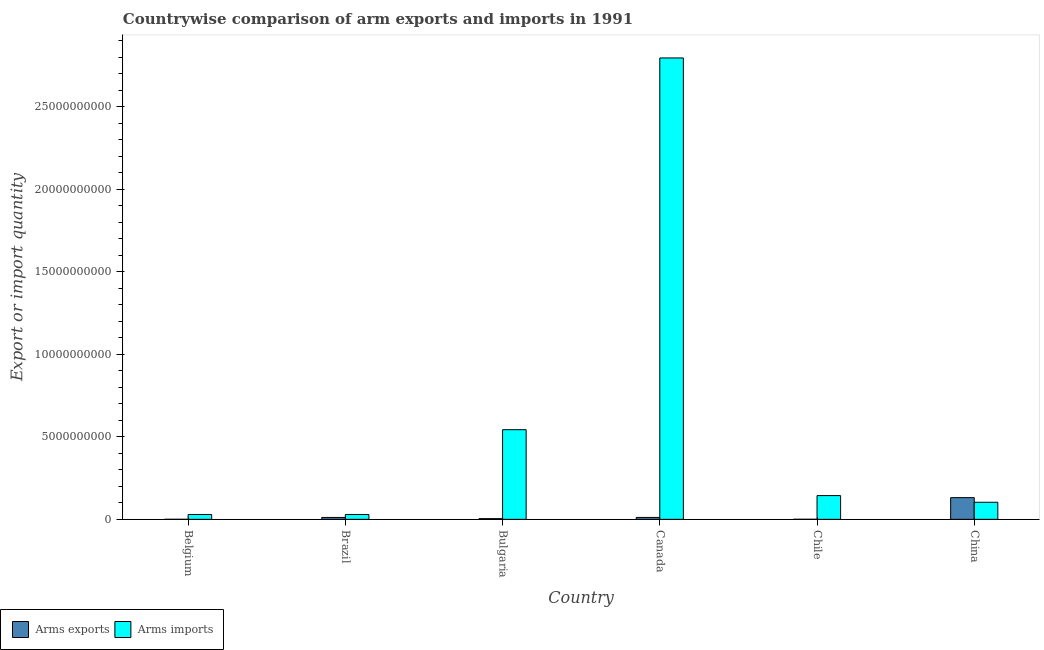How many groups of bars are there?
Your response must be concise. 6. Are the number of bars per tick equal to the number of legend labels?
Offer a very short reply. Yes. How many bars are there on the 3rd tick from the left?
Provide a succinct answer. 2. How many bars are there on the 1st tick from the right?
Ensure brevity in your answer.  2. What is the label of the 4th group of bars from the left?
Your answer should be compact. Canada. What is the arms imports in China?
Provide a short and direct response. 1.04e+09. Across all countries, what is the maximum arms imports?
Make the answer very short. 2.80e+1. Across all countries, what is the minimum arms imports?
Keep it short and to the point. 2.94e+08. In which country was the arms imports maximum?
Your answer should be very brief. Canada. What is the total arms exports in the graph?
Your response must be concise. 1.59e+09. What is the difference between the arms imports in Bulgaria and that in Chile?
Provide a short and direct response. 4.00e+09. What is the difference between the arms exports in China and the arms imports in Belgium?
Make the answer very short. 1.02e+09. What is the average arms exports per country?
Your answer should be compact. 2.65e+08. What is the difference between the arms imports and arms exports in Belgium?
Provide a succinct answer. 2.93e+08. In how many countries, is the arms imports greater than 28000000000 ?
Offer a very short reply. 0. What is the ratio of the arms imports in Brazil to that in Bulgaria?
Make the answer very short. 0.05. Is the arms exports in Belgium less than that in Brazil?
Give a very brief answer. Yes. What is the difference between the highest and the second highest arms imports?
Offer a very short reply. 2.25e+1. What is the difference between the highest and the lowest arms exports?
Offer a terse response. 1.31e+09. What does the 2nd bar from the left in Brazil represents?
Provide a short and direct response. Arms imports. What does the 2nd bar from the right in Canada represents?
Provide a short and direct response. Arms exports. Are the values on the major ticks of Y-axis written in scientific E-notation?
Offer a very short reply. No. Does the graph contain any zero values?
Your response must be concise. No. Does the graph contain grids?
Make the answer very short. No. How many legend labels are there?
Your response must be concise. 2. How are the legend labels stacked?
Offer a very short reply. Horizontal. What is the title of the graph?
Your answer should be compact. Countrywise comparison of arm exports and imports in 1991. What is the label or title of the Y-axis?
Provide a succinct answer. Export or import quantity. What is the Export or import quantity of Arms imports in Belgium?
Give a very brief answer. 2.94e+08. What is the Export or import quantity in Arms exports in Brazil?
Provide a short and direct response. 1.14e+08. What is the Export or import quantity of Arms imports in Brazil?
Ensure brevity in your answer.  2.94e+08. What is the Export or import quantity of Arms exports in Bulgaria?
Keep it short and to the point. 4.20e+07. What is the Export or import quantity of Arms imports in Bulgaria?
Give a very brief answer. 5.43e+09. What is the Export or import quantity of Arms exports in Canada?
Provide a short and direct response. 1.15e+08. What is the Export or import quantity of Arms imports in Canada?
Provide a succinct answer. 2.80e+1. What is the Export or import quantity in Arms imports in Chile?
Provide a short and direct response. 1.44e+09. What is the Export or import quantity of Arms exports in China?
Ensure brevity in your answer.  1.32e+09. What is the Export or import quantity of Arms imports in China?
Your answer should be very brief. 1.04e+09. Across all countries, what is the maximum Export or import quantity in Arms exports?
Offer a terse response. 1.32e+09. Across all countries, what is the maximum Export or import quantity of Arms imports?
Ensure brevity in your answer.  2.80e+1. Across all countries, what is the minimum Export or import quantity in Arms exports?
Your answer should be compact. 1.00e+06. Across all countries, what is the minimum Export or import quantity of Arms imports?
Offer a terse response. 2.94e+08. What is the total Export or import quantity of Arms exports in the graph?
Keep it short and to the point. 1.59e+09. What is the total Export or import quantity of Arms imports in the graph?
Keep it short and to the point. 3.65e+1. What is the difference between the Export or import quantity in Arms exports in Belgium and that in Brazil?
Offer a very short reply. -1.13e+08. What is the difference between the Export or import quantity in Arms imports in Belgium and that in Brazil?
Provide a succinct answer. 0. What is the difference between the Export or import quantity in Arms exports in Belgium and that in Bulgaria?
Your response must be concise. -4.10e+07. What is the difference between the Export or import quantity in Arms imports in Belgium and that in Bulgaria?
Keep it short and to the point. -5.14e+09. What is the difference between the Export or import quantity of Arms exports in Belgium and that in Canada?
Offer a very short reply. -1.14e+08. What is the difference between the Export or import quantity of Arms imports in Belgium and that in Canada?
Provide a succinct answer. -2.77e+1. What is the difference between the Export or import quantity in Arms exports in Belgium and that in Chile?
Offer a terse response. -2.00e+06. What is the difference between the Export or import quantity in Arms imports in Belgium and that in Chile?
Provide a succinct answer. -1.14e+09. What is the difference between the Export or import quantity in Arms exports in Belgium and that in China?
Keep it short and to the point. -1.31e+09. What is the difference between the Export or import quantity of Arms imports in Belgium and that in China?
Provide a short and direct response. -7.41e+08. What is the difference between the Export or import quantity in Arms exports in Brazil and that in Bulgaria?
Your answer should be compact. 7.20e+07. What is the difference between the Export or import quantity in Arms imports in Brazil and that in Bulgaria?
Your answer should be compact. -5.14e+09. What is the difference between the Export or import quantity of Arms exports in Brazil and that in Canada?
Offer a very short reply. -1.00e+06. What is the difference between the Export or import quantity of Arms imports in Brazil and that in Canada?
Give a very brief answer. -2.77e+1. What is the difference between the Export or import quantity in Arms exports in Brazil and that in Chile?
Provide a short and direct response. 1.11e+08. What is the difference between the Export or import quantity in Arms imports in Brazil and that in Chile?
Make the answer very short. -1.14e+09. What is the difference between the Export or import quantity in Arms exports in Brazil and that in China?
Your answer should be very brief. -1.20e+09. What is the difference between the Export or import quantity in Arms imports in Brazil and that in China?
Make the answer very short. -7.41e+08. What is the difference between the Export or import quantity of Arms exports in Bulgaria and that in Canada?
Offer a very short reply. -7.30e+07. What is the difference between the Export or import quantity of Arms imports in Bulgaria and that in Canada?
Provide a short and direct response. -2.25e+1. What is the difference between the Export or import quantity of Arms exports in Bulgaria and that in Chile?
Provide a succinct answer. 3.90e+07. What is the difference between the Export or import quantity in Arms imports in Bulgaria and that in Chile?
Ensure brevity in your answer.  4.00e+09. What is the difference between the Export or import quantity in Arms exports in Bulgaria and that in China?
Offer a terse response. -1.27e+09. What is the difference between the Export or import quantity in Arms imports in Bulgaria and that in China?
Your response must be concise. 4.40e+09. What is the difference between the Export or import quantity in Arms exports in Canada and that in Chile?
Ensure brevity in your answer.  1.12e+08. What is the difference between the Export or import quantity of Arms imports in Canada and that in Chile?
Give a very brief answer. 2.65e+1. What is the difference between the Export or import quantity of Arms exports in Canada and that in China?
Your answer should be very brief. -1.20e+09. What is the difference between the Export or import quantity of Arms imports in Canada and that in China?
Offer a terse response. 2.69e+1. What is the difference between the Export or import quantity in Arms exports in Chile and that in China?
Make the answer very short. -1.31e+09. What is the difference between the Export or import quantity of Arms imports in Chile and that in China?
Your answer should be compact. 4.03e+08. What is the difference between the Export or import quantity in Arms exports in Belgium and the Export or import quantity in Arms imports in Brazil?
Keep it short and to the point. -2.93e+08. What is the difference between the Export or import quantity in Arms exports in Belgium and the Export or import quantity in Arms imports in Bulgaria?
Offer a terse response. -5.43e+09. What is the difference between the Export or import quantity in Arms exports in Belgium and the Export or import quantity in Arms imports in Canada?
Keep it short and to the point. -2.80e+1. What is the difference between the Export or import quantity in Arms exports in Belgium and the Export or import quantity in Arms imports in Chile?
Keep it short and to the point. -1.44e+09. What is the difference between the Export or import quantity in Arms exports in Belgium and the Export or import quantity in Arms imports in China?
Ensure brevity in your answer.  -1.03e+09. What is the difference between the Export or import quantity of Arms exports in Brazil and the Export or import quantity of Arms imports in Bulgaria?
Keep it short and to the point. -5.32e+09. What is the difference between the Export or import quantity in Arms exports in Brazil and the Export or import quantity in Arms imports in Canada?
Your answer should be compact. -2.78e+1. What is the difference between the Export or import quantity of Arms exports in Brazil and the Export or import quantity of Arms imports in Chile?
Give a very brief answer. -1.32e+09. What is the difference between the Export or import quantity of Arms exports in Brazil and the Export or import quantity of Arms imports in China?
Provide a succinct answer. -9.21e+08. What is the difference between the Export or import quantity of Arms exports in Bulgaria and the Export or import quantity of Arms imports in Canada?
Provide a short and direct response. -2.79e+1. What is the difference between the Export or import quantity of Arms exports in Bulgaria and the Export or import quantity of Arms imports in Chile?
Provide a succinct answer. -1.40e+09. What is the difference between the Export or import quantity in Arms exports in Bulgaria and the Export or import quantity in Arms imports in China?
Offer a very short reply. -9.93e+08. What is the difference between the Export or import quantity of Arms exports in Canada and the Export or import quantity of Arms imports in Chile?
Provide a succinct answer. -1.32e+09. What is the difference between the Export or import quantity of Arms exports in Canada and the Export or import quantity of Arms imports in China?
Keep it short and to the point. -9.20e+08. What is the difference between the Export or import quantity in Arms exports in Chile and the Export or import quantity in Arms imports in China?
Your answer should be compact. -1.03e+09. What is the average Export or import quantity of Arms exports per country?
Keep it short and to the point. 2.65e+08. What is the average Export or import quantity of Arms imports per country?
Ensure brevity in your answer.  6.08e+09. What is the difference between the Export or import quantity of Arms exports and Export or import quantity of Arms imports in Belgium?
Ensure brevity in your answer.  -2.93e+08. What is the difference between the Export or import quantity of Arms exports and Export or import quantity of Arms imports in Brazil?
Your response must be concise. -1.80e+08. What is the difference between the Export or import quantity in Arms exports and Export or import quantity in Arms imports in Bulgaria?
Ensure brevity in your answer.  -5.39e+09. What is the difference between the Export or import quantity of Arms exports and Export or import quantity of Arms imports in Canada?
Make the answer very short. -2.78e+1. What is the difference between the Export or import quantity of Arms exports and Export or import quantity of Arms imports in Chile?
Give a very brief answer. -1.44e+09. What is the difference between the Export or import quantity of Arms exports and Export or import quantity of Arms imports in China?
Your answer should be very brief. 2.80e+08. What is the ratio of the Export or import quantity in Arms exports in Belgium to that in Brazil?
Your answer should be compact. 0.01. What is the ratio of the Export or import quantity of Arms imports in Belgium to that in Brazil?
Make the answer very short. 1. What is the ratio of the Export or import quantity in Arms exports in Belgium to that in Bulgaria?
Your answer should be compact. 0.02. What is the ratio of the Export or import quantity in Arms imports in Belgium to that in Bulgaria?
Your response must be concise. 0.05. What is the ratio of the Export or import quantity in Arms exports in Belgium to that in Canada?
Offer a very short reply. 0.01. What is the ratio of the Export or import quantity in Arms imports in Belgium to that in Canada?
Provide a short and direct response. 0.01. What is the ratio of the Export or import quantity in Arms imports in Belgium to that in Chile?
Your answer should be very brief. 0.2. What is the ratio of the Export or import quantity in Arms exports in Belgium to that in China?
Ensure brevity in your answer.  0. What is the ratio of the Export or import quantity in Arms imports in Belgium to that in China?
Give a very brief answer. 0.28. What is the ratio of the Export or import quantity in Arms exports in Brazil to that in Bulgaria?
Offer a terse response. 2.71. What is the ratio of the Export or import quantity in Arms imports in Brazil to that in Bulgaria?
Your answer should be very brief. 0.05. What is the ratio of the Export or import quantity of Arms exports in Brazil to that in Canada?
Your answer should be compact. 0.99. What is the ratio of the Export or import quantity of Arms imports in Brazil to that in Canada?
Ensure brevity in your answer.  0.01. What is the ratio of the Export or import quantity in Arms imports in Brazil to that in Chile?
Make the answer very short. 0.2. What is the ratio of the Export or import quantity of Arms exports in Brazil to that in China?
Make the answer very short. 0.09. What is the ratio of the Export or import quantity in Arms imports in Brazil to that in China?
Ensure brevity in your answer.  0.28. What is the ratio of the Export or import quantity in Arms exports in Bulgaria to that in Canada?
Your answer should be very brief. 0.37. What is the ratio of the Export or import quantity of Arms imports in Bulgaria to that in Canada?
Offer a terse response. 0.19. What is the ratio of the Export or import quantity of Arms exports in Bulgaria to that in Chile?
Offer a terse response. 14. What is the ratio of the Export or import quantity of Arms imports in Bulgaria to that in Chile?
Give a very brief answer. 3.78. What is the ratio of the Export or import quantity of Arms exports in Bulgaria to that in China?
Your answer should be compact. 0.03. What is the ratio of the Export or import quantity of Arms imports in Bulgaria to that in China?
Keep it short and to the point. 5.25. What is the ratio of the Export or import quantity of Arms exports in Canada to that in Chile?
Provide a succinct answer. 38.33. What is the ratio of the Export or import quantity of Arms imports in Canada to that in Chile?
Offer a terse response. 19.45. What is the ratio of the Export or import quantity of Arms exports in Canada to that in China?
Provide a short and direct response. 0.09. What is the ratio of the Export or import quantity in Arms imports in Canada to that in China?
Make the answer very short. 27.02. What is the ratio of the Export or import quantity in Arms exports in Chile to that in China?
Keep it short and to the point. 0. What is the ratio of the Export or import quantity in Arms imports in Chile to that in China?
Provide a succinct answer. 1.39. What is the difference between the highest and the second highest Export or import quantity of Arms exports?
Ensure brevity in your answer.  1.20e+09. What is the difference between the highest and the second highest Export or import quantity of Arms imports?
Provide a succinct answer. 2.25e+1. What is the difference between the highest and the lowest Export or import quantity in Arms exports?
Ensure brevity in your answer.  1.31e+09. What is the difference between the highest and the lowest Export or import quantity in Arms imports?
Your answer should be compact. 2.77e+1. 